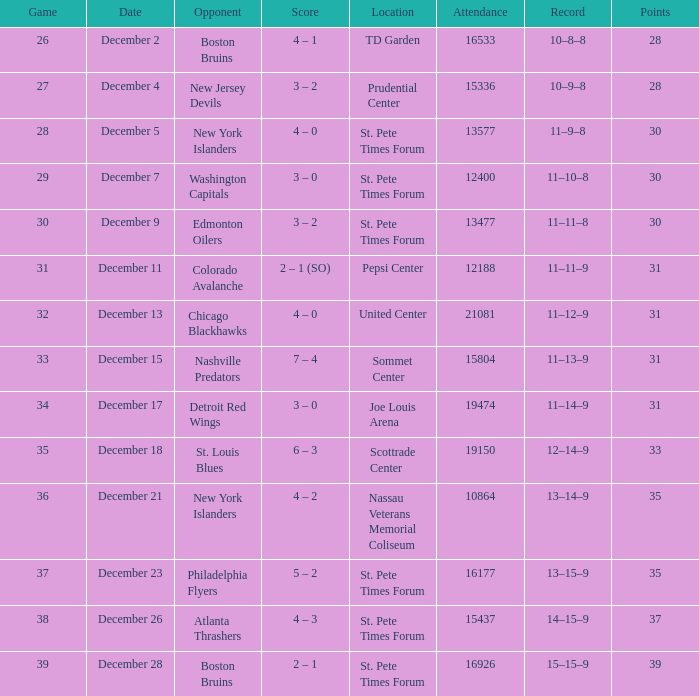What game holds the record for the most attendees? 21081.0. 